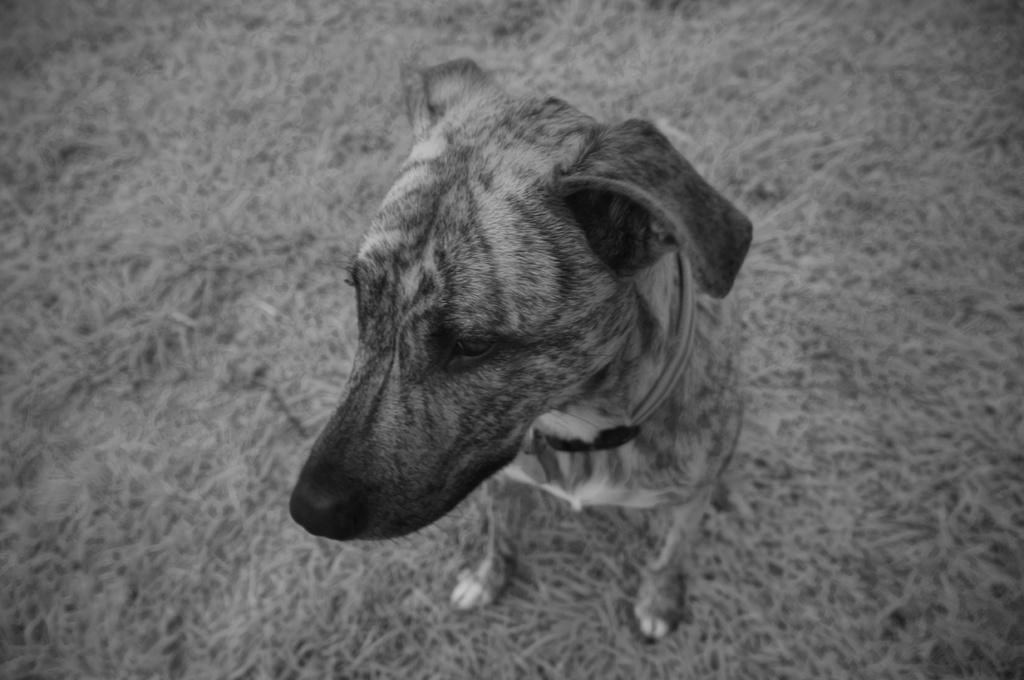What type of animal is present in the image? There is a dog in the image. What color scheme is used in the image? The image is in black and white color. What type of railway is visible in the image? There is no railway present in the image; it features a dog in black and white. What kind of marble is being used to create the dog's fur in the image? The image is in black and white, so there is no marble texture or material used to create the dog's fur. 